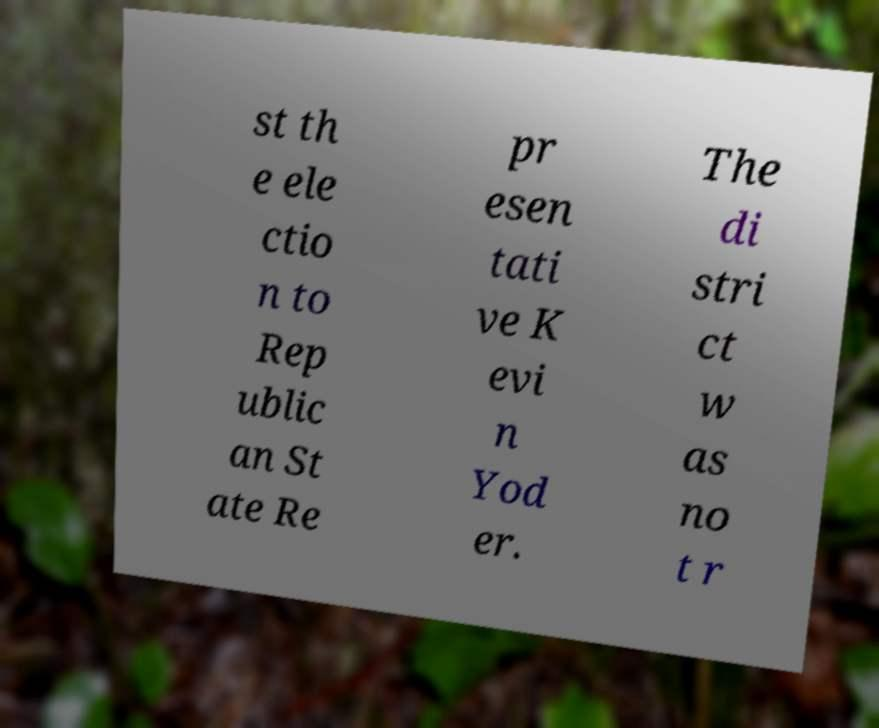Could you extract and type out the text from this image? st th e ele ctio n to Rep ublic an St ate Re pr esen tati ve K evi n Yod er. The di stri ct w as no t r 